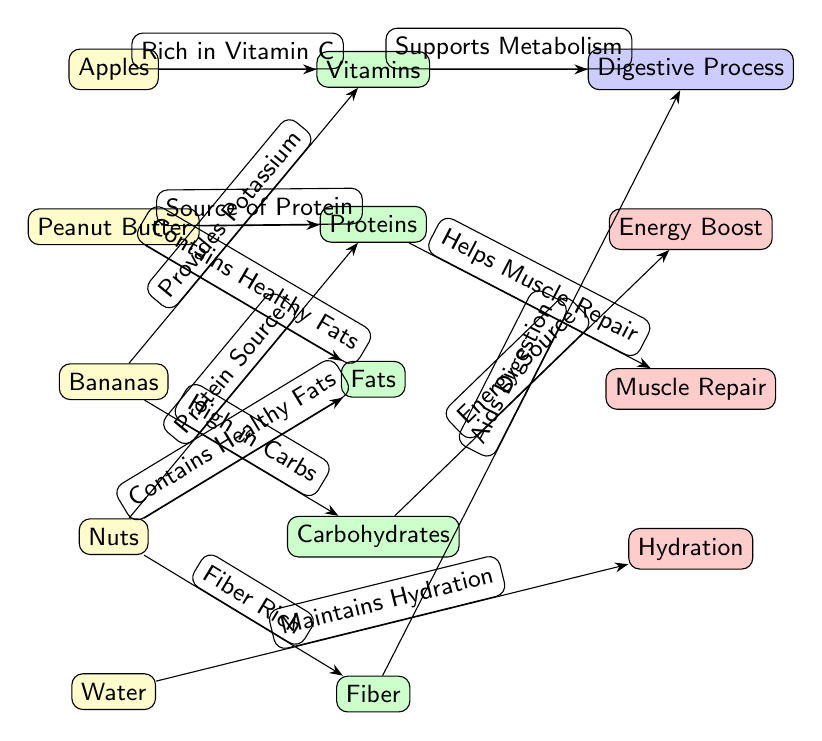What are the ingredients listed in the diagram? The diagram lists five ingredients: Apples, Peanut Butter, Bananas, Nuts, and Water. These can be identified at the left side of the diagram, which clearly shows the ingredient nodes.
Answer: Apples, Peanut Butter, Bananas, Nuts, Water Which ingredient is a source of protein? The diagram shows that two ingredients, Peanut Butter and Nuts, are identified as sources of protein, as labeled in the respective edges connecting them to the Proteins nutrient node.
Answer: Peanut Butter, Nuts How many nutrients are depicted in the diagram? There are five nutrients shown on the right side of the diagram: Vitamins, Proteins, Fats, Carbohydrates, and Fiber. Counting these nodes results in a total of five nutrients.
Answer: 5 What nutrient aids in digestion? The diagram indicates that Fiber aids digestion, as shown by the edge connecting Fiber to the Digestive Process node, highlighting its role in the digestion process.
Answer: Fiber Which ingredient helps with hydration? According to the diagram, Water is identified as the ingredient that helps maintain hydration, as represented by the edge linking Water to the Hydration benefit node.
Answer: Water What is the relationship between carbohydrates and energy boost? The diagram illustrates that Carbohydrates are described as an Energy Source, forming a direct connection to the Energy Boost benefit node with the respective edge, signifying their relationship.
Answer: Energy Source What nutrient is rich in vitamin C? The diagram identifies Apples as rich in Vitamin C, evidenced by the edge that connects the ingredient node for Apples to the Vitamins nutrient node.
Answer: Vitamins Which ingredient provides potassium? The diagram specifies that Bananas provide Potassium, as indicated by the edge linking Bananas to the Vitamins nutrient node, signifying their contribution.
Answer: Bananas What benefit do proteins provide? The diagram states that Proteins help with Muscle Repair, which is highlighted by the edge that connects the Proteins nutrient to the Muscle Repair benefit node.
Answer: Muscle Repair 